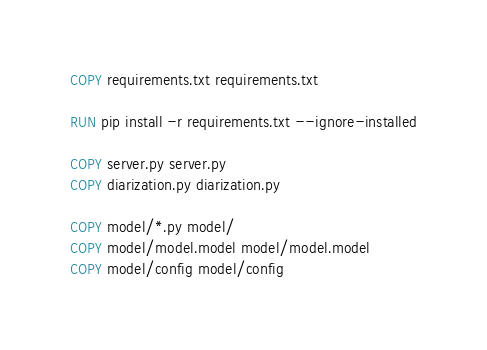Convert code to text. <code><loc_0><loc_0><loc_500><loc_500><_Dockerfile_>COPY requirements.txt requirements.txt

RUN pip install -r requirements.txt --ignore-installed

COPY server.py server.py
COPY diarization.py diarization.py

COPY model/*.py model/
COPY model/model.model model/model.model
COPY model/config model/config</code> 